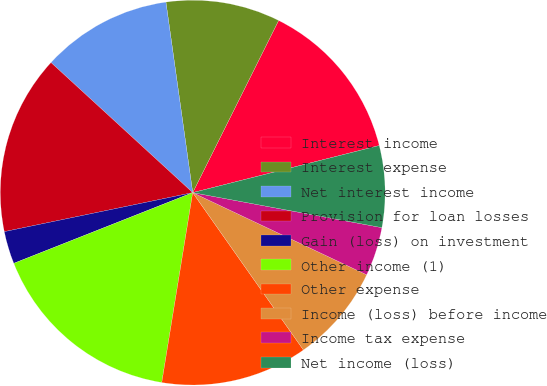Convert chart to OTSL. <chart><loc_0><loc_0><loc_500><loc_500><pie_chart><fcel>Interest income<fcel>Interest expense<fcel>Net interest income<fcel>Provision for loan losses<fcel>Gain (loss) on investment<fcel>Other income (1)<fcel>Other expense<fcel>Income (loss) before income<fcel>Income tax expense<fcel>Net income (loss)<nl><fcel>13.7%<fcel>9.59%<fcel>10.96%<fcel>15.07%<fcel>2.74%<fcel>16.44%<fcel>12.33%<fcel>8.22%<fcel>4.11%<fcel>6.85%<nl></chart> 